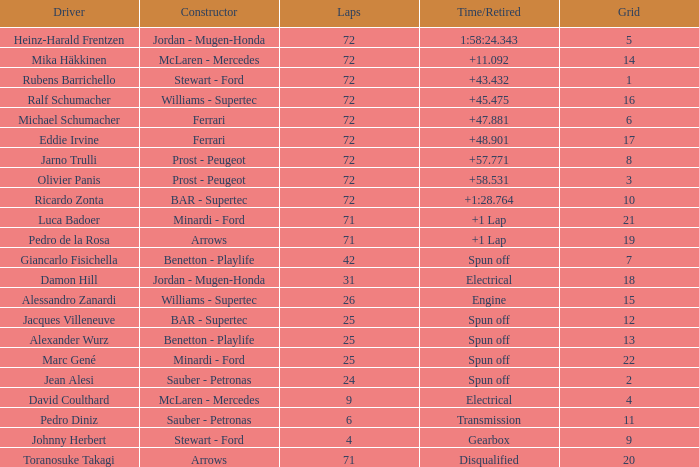How many laps did Ricardo Zonta drive with a grid less than 14? 72.0. 